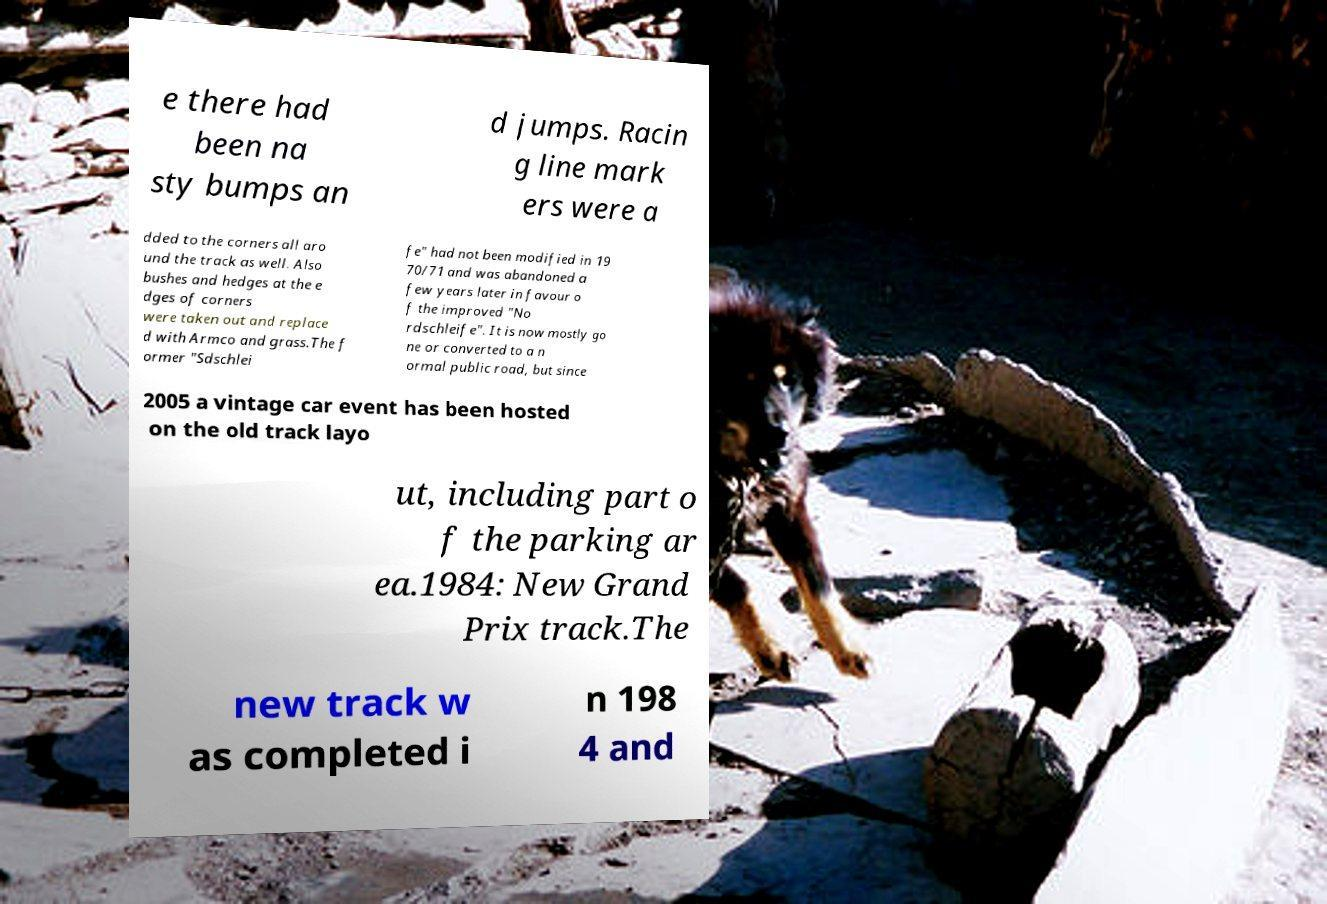Could you assist in decoding the text presented in this image and type it out clearly? e there had been na sty bumps an d jumps. Racin g line mark ers were a dded to the corners all aro und the track as well. Also bushes and hedges at the e dges of corners were taken out and replace d with Armco and grass.The f ormer "Sdschlei fe" had not been modified in 19 70/71 and was abandoned a few years later in favour o f the improved "No rdschleife". It is now mostly go ne or converted to a n ormal public road, but since 2005 a vintage car event has been hosted on the old track layo ut, including part o f the parking ar ea.1984: New Grand Prix track.The new track w as completed i n 198 4 and 